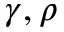Convert formula to latex. <formula><loc_0><loc_0><loc_500><loc_500>\gamma , \rho</formula> 